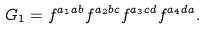Convert formula to latex. <formula><loc_0><loc_0><loc_500><loc_500>G _ { 1 } = f ^ { a _ { 1 } a b } f ^ { a _ { 2 } b c } f ^ { a _ { 3 } c d } f ^ { a _ { 4 } d a } .</formula> 